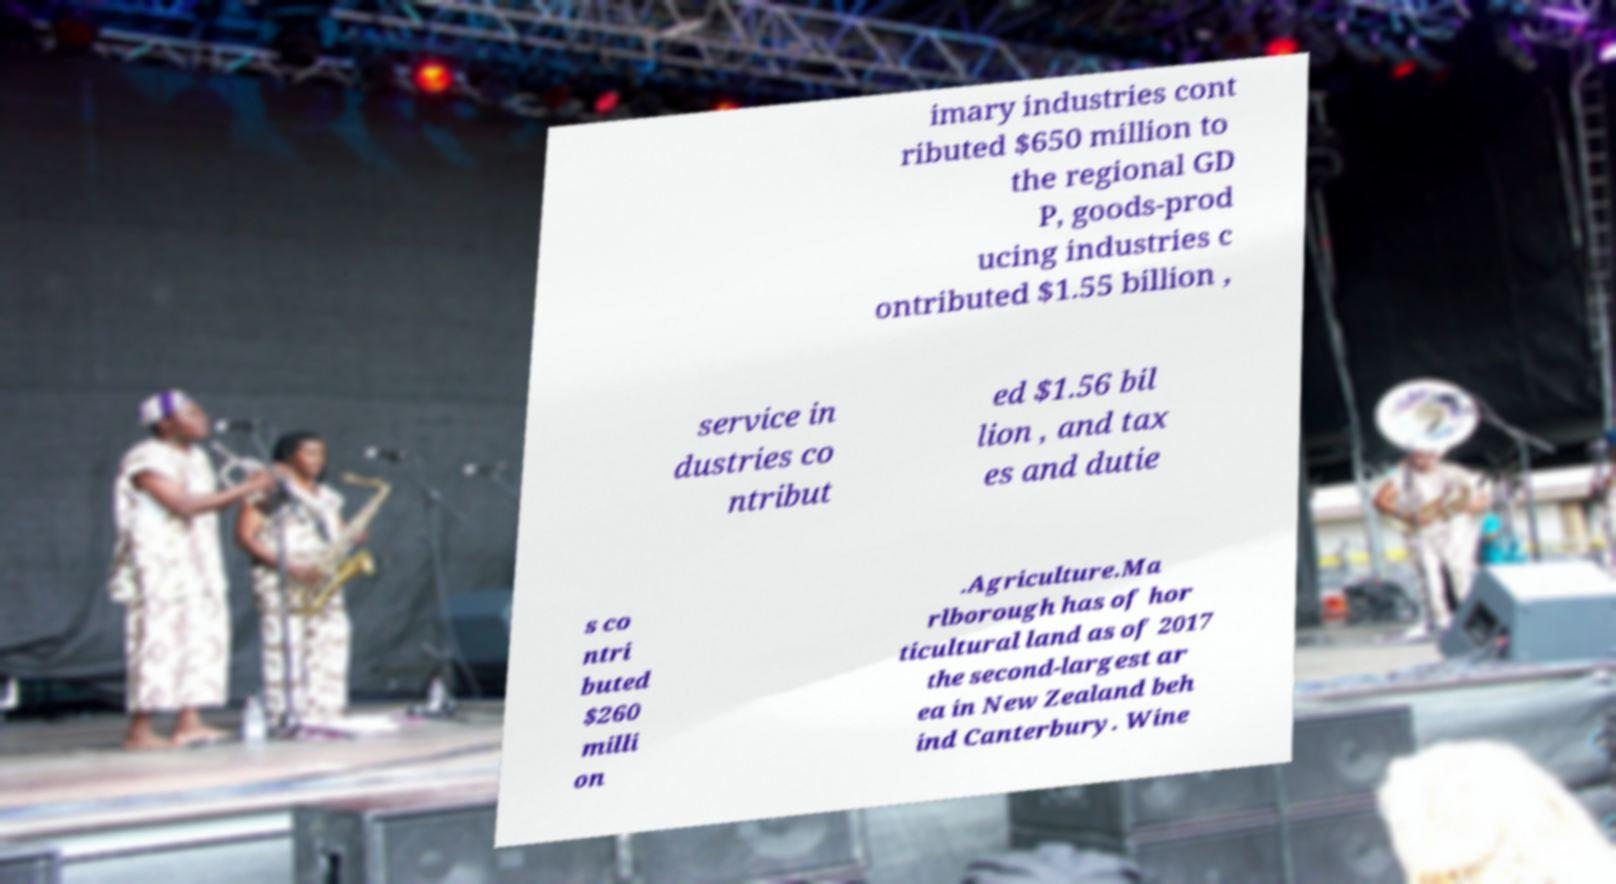For documentation purposes, I need the text within this image transcribed. Could you provide that? imary industries cont ributed $650 million to the regional GD P, goods-prod ucing industries c ontributed $1.55 billion , service in dustries co ntribut ed $1.56 bil lion , and tax es and dutie s co ntri buted $260 milli on .Agriculture.Ma rlborough has of hor ticultural land as of 2017 the second-largest ar ea in New Zealand beh ind Canterbury. Wine 